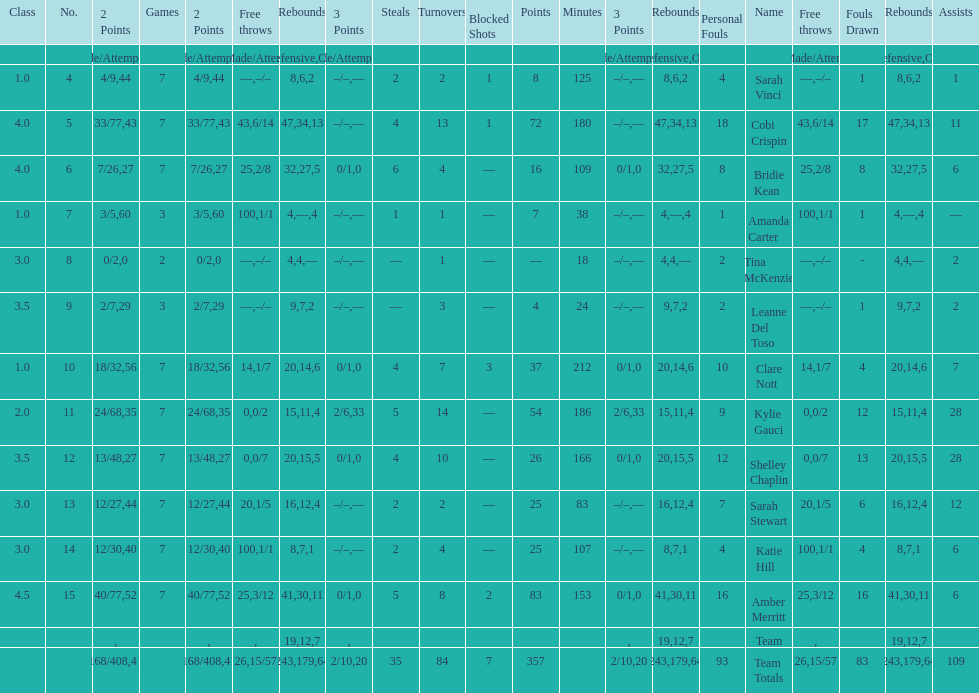Total number of assists and turnovers combined 193. Help me parse the entirety of this table. {'header': ['Class', 'No.', '2 Points', 'Games', '2 Points', 'Free throws', 'Rebounds', '3 Points', 'Steals', 'Turnovers', 'Blocked Shots', 'Points', 'Minutes', '3 Points', 'Rebounds', 'Personal Fouls', 'Name', 'Free throws', 'Fouls Drawn', 'Rebounds', 'Assists'], 'rows': [['', '', 'Made/Attempts', '', '%', '%', 'Total', 'Made/Attempts', '', '', '', '', '', '%', 'Defensive', '', '', 'Made/Attempts', '', 'Offensive', ''], ['1.0', '4', '4/9', '7', '44', '—', '8', '–/–', '2', '2', '1', '8', '125', '—', '6', '4', 'Sarah Vinci', '–/–', '1', '2', '1'], ['4.0', '5', '33/77', '7', '43', '43', '47', '–/–', '4', '13', '1', '72', '180', '—', '34', '18', 'Cobi Crispin', '6/14', '17', '13', '11'], ['4.0', '6', '7/26', '7', '27', '25', '32', '0/1', '6', '4', '—', '16', '109', '0', '27', '8', 'Bridie Kean', '2/8', '8', '5', '6'], ['1.0', '7', '3/5', '3', '60', '100', '4', '–/–', '1', '1', '—', '7', '38', '—', '—', '1', 'Amanda Carter', '1/1', '1', '4', '—'], ['3.0', '8', '0/2', '2', '0', '—', '4', '–/–', '—', '1', '—', '—', '18', '—', '4', '2', 'Tina McKenzie', '–/–', '-', '—', '2'], ['3.5', '9', '2/7', '3', '29', '—', '9', '–/–', '—', '3', '—', '4', '24', '—', '7', '2', 'Leanne Del Toso', '–/–', '1', '2', '2'], ['1.0', '10', '18/32', '7', '56', '14', '20', '0/1', '4', '7', '3', '37', '212', '0', '14', '10', 'Clare Nott', '1/7', '4', '6', '7'], ['2.0', '11', '24/68', '7', '35', '0', '15', '2/6', '5', '14', '—', '54', '186', '33', '11', '9', 'Kylie Gauci', '0/2', '12', '4', '28'], ['3.5', '12', '13/48', '7', '27', '0', '20', '0/1', '4', '10', '—', '26', '166', '0', '15', '12', 'Shelley Chaplin', '0/7', '13', '5', '28'], ['3.0', '13', '12/27', '7', '44', '20', '16', '–/–', '2', '2', '—', '25', '83', '—', '12', '7', 'Sarah Stewart', '1/5', '6', '4', '12'], ['3.0', '14', '12/30', '7', '40', '100', '8', '–/–', '2', '4', '—', '25', '107', '—', '7', '4', 'Katie Hill', '1/1', '4', '1', '6'], ['4.5', '15', '40/77', '7', '52', '25', '41', '0/1', '5', '8', '2', '83', '153', '0', '30', '16', 'Amber Merritt', '3/12', '16', '11', '6'], ['', '', '', '', '', '', '19', '', '', '', '', '', '', '', '12', '', 'Team', '', '', '7', ''], ['', '', '168/408', '', '41', '26', '243', '2/10', '35', '84', '7', '357', '', '20', '179', '93', 'Team Totals', '15/57', '83', '64', '109']]} 